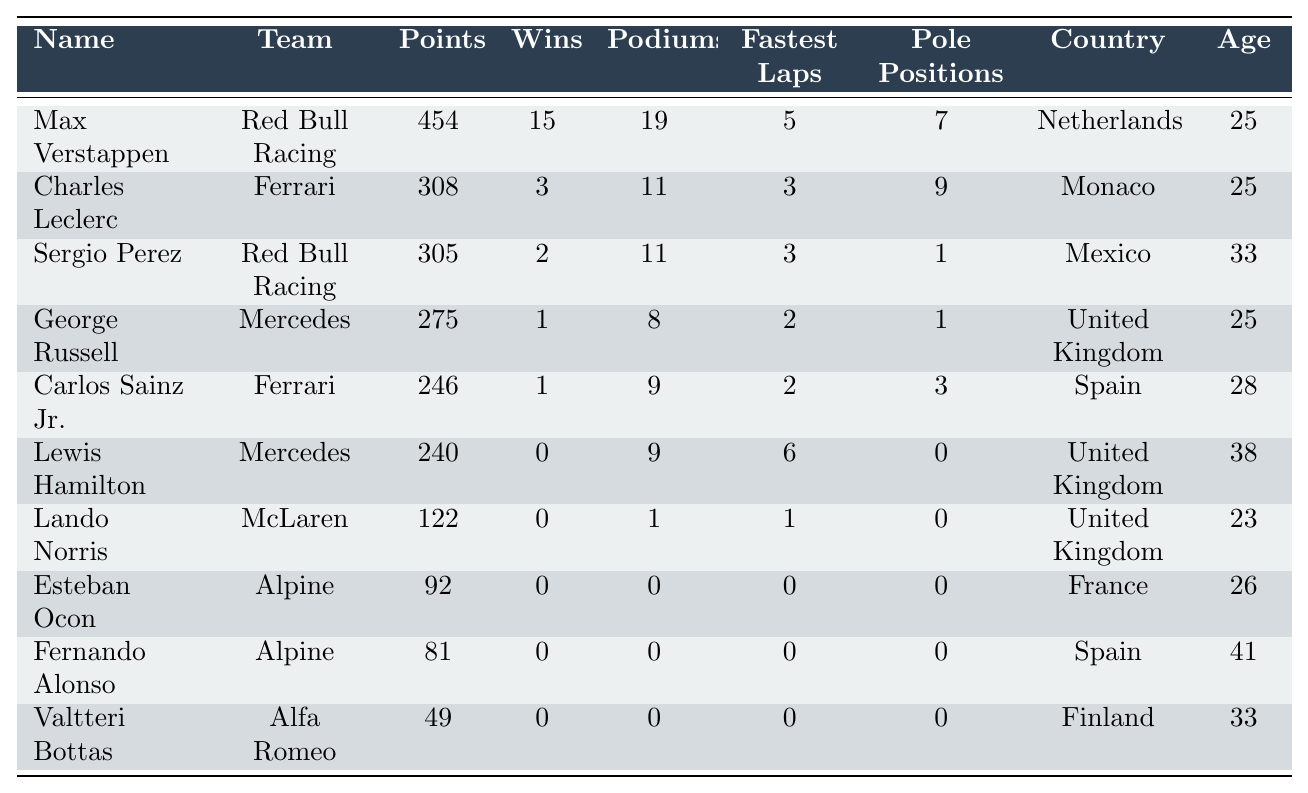What is the country of the driver with the most points? The driver with the most points is Max Verstappen, who has 454 points. According to the table, he is from the Netherlands.
Answer: Netherlands How many wins did Lewis Hamilton have last season? The table shows that Lewis Hamilton had 0 wins last season.
Answer: 0 Which driver scored the least points? The driver with the least points is Valtteri Bottas with 49 points.
Answer: 49 What is the total number of wins by the top three drivers? The top three drivers are Max Verstappen (15 wins), Charles Leclerc (3 wins), and Sergio Perez (2 wins). Summing them: 15 + 3 + 2 = 20.
Answer: 20 Which country had the most drivers in the top 10? The United Kingdom has three drivers in the top 10: George Russell, Lewis Hamilton, and Lando Norris. Therefore, it had the most drivers.
Answer: United Kingdom What is the average age of the top 10 drivers? The ages are: 25, 25, 33, 25, 28, 38, 23, 26, 41, and 33. Sum: 25 + 25 + 33 + 25 + 28 + 38 + 23 + 26 + 41 + 33 =  6. Divide by 10 to get the average:  6/10 = 32.5.
Answer: 32.5 Did any driver win at least 15 races? Yes, Max Verstappen won 15 races last season. According to the table, he is the only driver who achieved this.
Answer: Yes How many drivers scored more than 200 points? Looking at the points, the drivers with more than 200 points are Max Verstappen (454), Charles Leclerc (308), Sergio Perez (305), George Russell (275), Carlos Sainz Jr. (246), and Lewis Hamilton (240). That's a total of 6 drivers.
Answer: 6 Which driver had the highest number of podium finishes? Max Verstappen had the highest number of podiums with 19 finishes.
Answer: 19 What is the total number of fastest laps scored by the top 10 drivers? The fastest laps are: 5 (Verstappen), 3 (Leclerc), 3 (Perez), 2 (Russell), 2 (Sainz), 6 (Hamilton), 1 (Norris), 0 (Ocon), 0 (Alonso), and 0 (Bottas). Sum: 5 + 3 + 3 + 2 + 2 + 6 + 1 + 0 + 0 + 0 = 22.
Answer: 22 How many drivers belong to the Ferrari team in the top 10? The table indicates that Charles Leclerc and Carlos Sainz Jr. are the two drivers from Ferrari in the top 10.
Answer: 2 